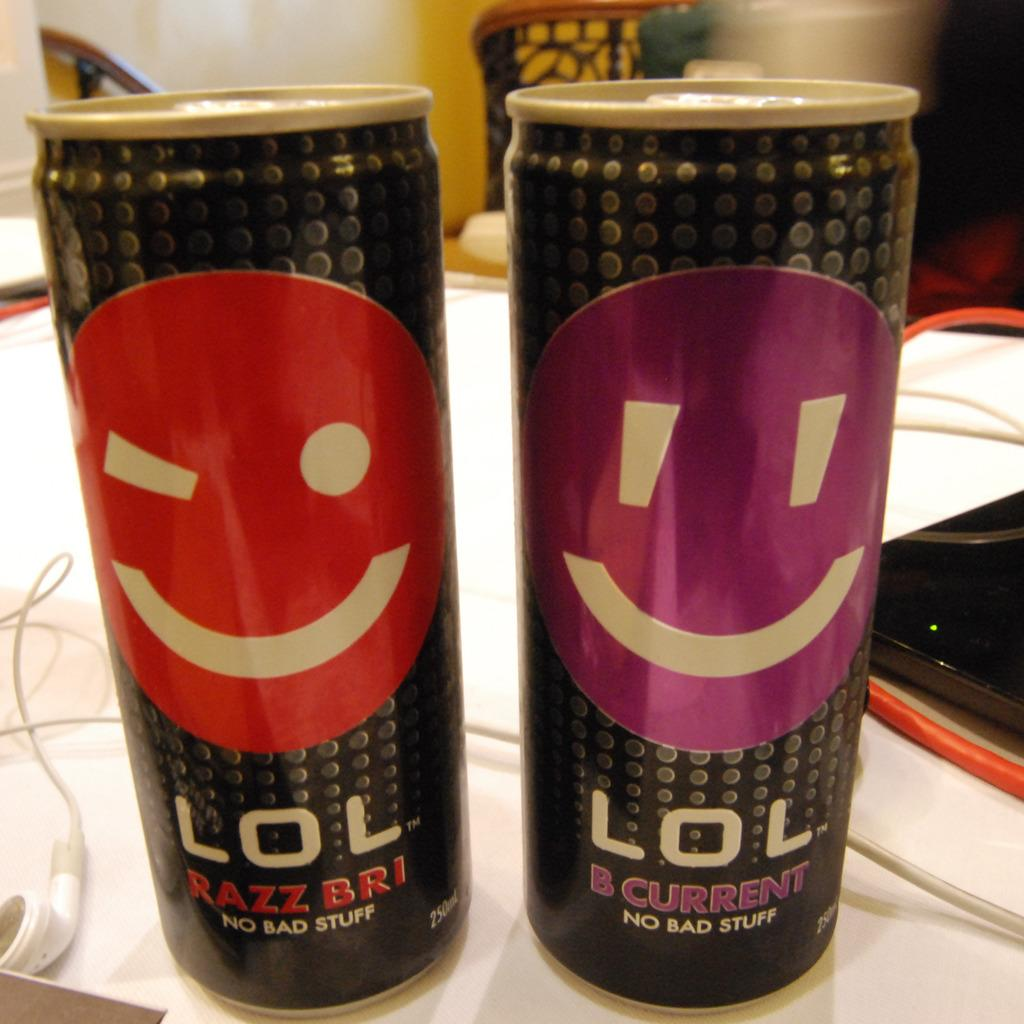<image>
Describe the image concisely. Two drink cans called LOL with emojis are them are sitting by each ohter. 